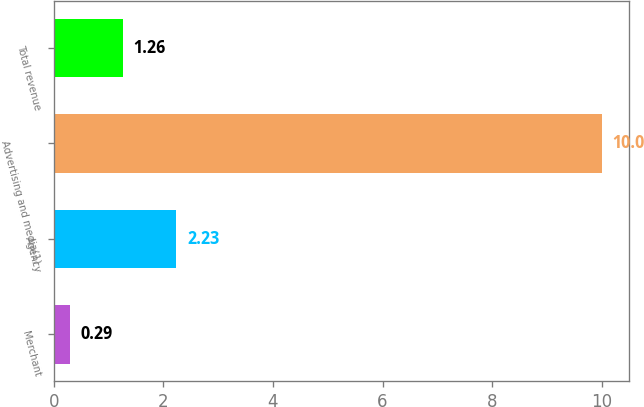Convert chart. <chart><loc_0><loc_0><loc_500><loc_500><bar_chart><fcel>Merchant<fcel>Agency<fcel>Advertising and media(1)<fcel>Total revenue<nl><fcel>0.29<fcel>2.23<fcel>10<fcel>1.26<nl></chart> 